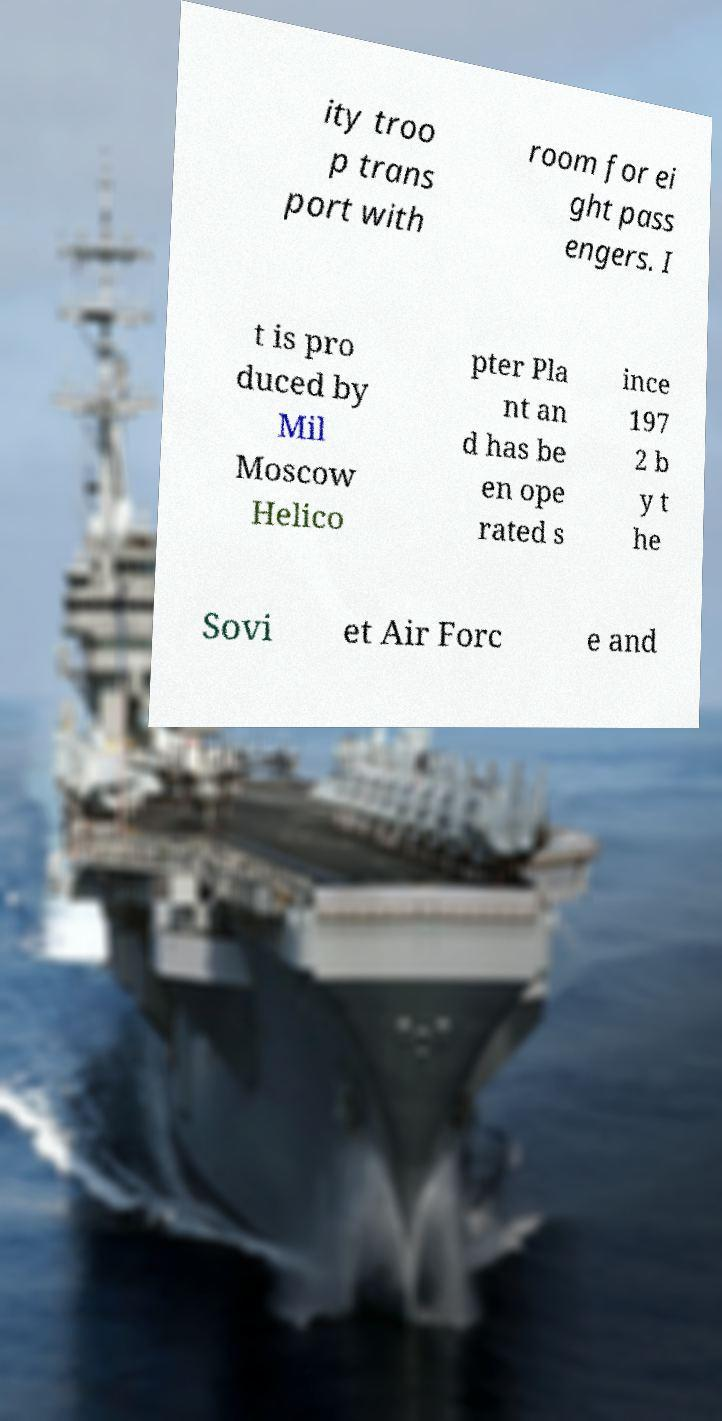For documentation purposes, I need the text within this image transcribed. Could you provide that? ity troo p trans port with room for ei ght pass engers. I t is pro duced by Mil Moscow Helico pter Pla nt an d has be en ope rated s ince 197 2 b y t he Sovi et Air Forc e and 